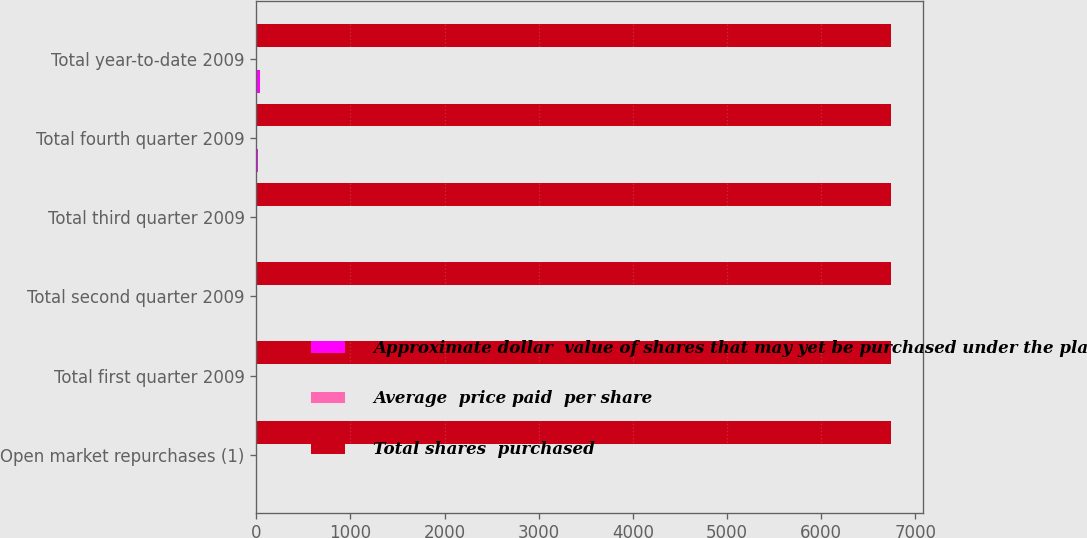Convert chart. <chart><loc_0><loc_0><loc_500><loc_500><stacked_bar_chart><ecel><fcel>Open market repurchases (1)<fcel>Total first quarter 2009<fcel>Total second quarter 2009<fcel>Total third quarter 2009<fcel>Total fourth quarter 2009<fcel>Total year-to-date 2009<nl><fcel>Approximate dollar  value of shares that may yet be purchased under the plan or programs<fcel>0.2<fcel>10.9<fcel>4.6<fcel>1.8<fcel>19.8<fcel>37.1<nl><fcel>Average  price paid  per share<fcel>3.03<fcel>3.55<fcel>3.65<fcel>3.22<fcel>3.76<fcel>3.66<nl><fcel>Total shares  purchased<fcel>6741<fcel>6741<fcel>6740<fcel>6739<fcel>6739<fcel>6739<nl></chart> 